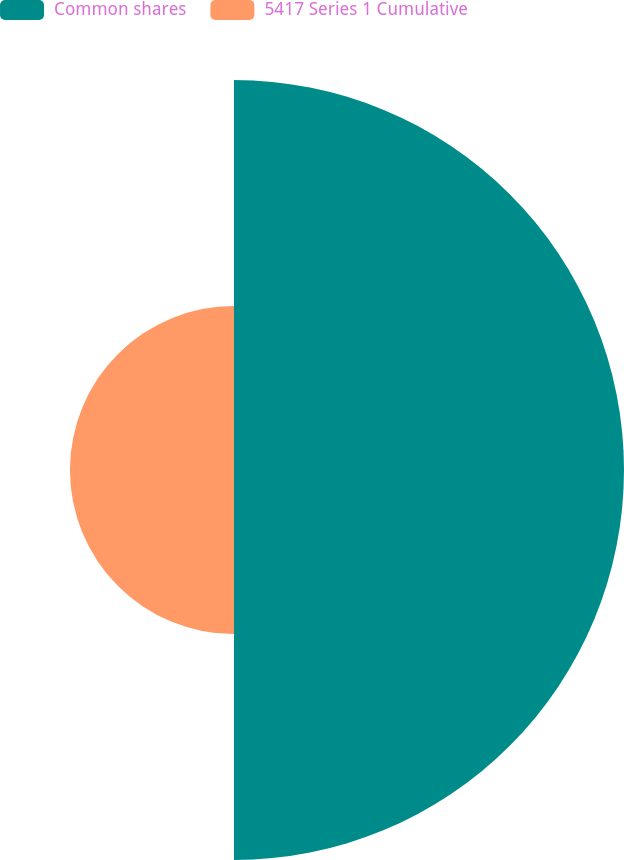Convert chart. <chart><loc_0><loc_0><loc_500><loc_500><pie_chart><fcel>Common shares<fcel>5417 Series 1 Cumulative<nl><fcel>70.39%<fcel>29.61%<nl></chart> 